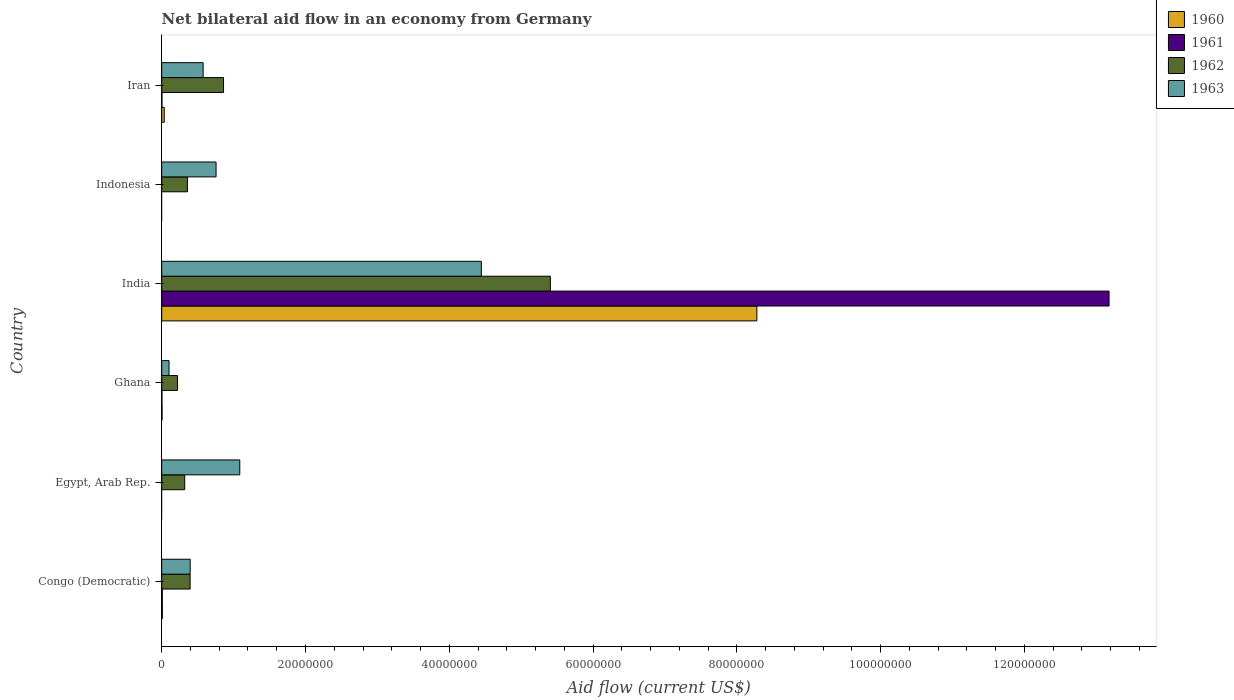How many groups of bars are there?
Provide a short and direct response. 6. How many bars are there on the 6th tick from the bottom?
Keep it short and to the point. 4. Across all countries, what is the maximum net bilateral aid flow in 1961?
Give a very brief answer. 1.32e+08. Across all countries, what is the minimum net bilateral aid flow in 1960?
Make the answer very short. 0. In which country was the net bilateral aid flow in 1960 maximum?
Provide a short and direct response. India. What is the total net bilateral aid flow in 1963 in the graph?
Ensure brevity in your answer.  7.36e+07. What is the difference between the net bilateral aid flow in 1962 in Congo (Democratic) and that in Iran?
Your answer should be very brief. -4.65e+06. What is the difference between the net bilateral aid flow in 1960 in Egypt, Arab Rep. and the net bilateral aid flow in 1963 in Indonesia?
Ensure brevity in your answer.  -7.56e+06. What is the average net bilateral aid flow in 1961 per country?
Give a very brief answer. 2.20e+07. What is the difference between the net bilateral aid flow in 1962 and net bilateral aid flow in 1963 in Iran?
Make the answer very short. 2.84e+06. In how many countries, is the net bilateral aid flow in 1960 greater than 116000000 US$?
Ensure brevity in your answer.  0. What is the ratio of the net bilateral aid flow in 1962 in Congo (Democratic) to that in Egypt, Arab Rep.?
Ensure brevity in your answer.  1.23. What is the difference between the highest and the second highest net bilateral aid flow in 1962?
Make the answer very short. 4.55e+07. What is the difference between the highest and the lowest net bilateral aid flow in 1960?
Ensure brevity in your answer.  8.28e+07. In how many countries, is the net bilateral aid flow in 1961 greater than the average net bilateral aid flow in 1961 taken over all countries?
Your response must be concise. 1. Is the sum of the net bilateral aid flow in 1962 in Ghana and Iran greater than the maximum net bilateral aid flow in 1963 across all countries?
Your answer should be compact. No. Is it the case that in every country, the sum of the net bilateral aid flow in 1960 and net bilateral aid flow in 1963 is greater than the sum of net bilateral aid flow in 1961 and net bilateral aid flow in 1962?
Keep it short and to the point. No. Is it the case that in every country, the sum of the net bilateral aid flow in 1963 and net bilateral aid flow in 1961 is greater than the net bilateral aid flow in 1962?
Your answer should be compact. No. How many bars are there?
Your answer should be compact. 20. Are all the bars in the graph horizontal?
Your answer should be compact. Yes. What is the difference between two consecutive major ticks on the X-axis?
Provide a succinct answer. 2.00e+07. Are the values on the major ticks of X-axis written in scientific E-notation?
Your response must be concise. No. Does the graph contain any zero values?
Provide a succinct answer. Yes. Does the graph contain grids?
Make the answer very short. No. Where does the legend appear in the graph?
Offer a very short reply. Top right. How many legend labels are there?
Provide a succinct answer. 4. What is the title of the graph?
Offer a very short reply. Net bilateral aid flow in an economy from Germany. What is the Aid flow (current US$) in 1960 in Congo (Democratic)?
Provide a succinct answer. 9.00e+04. What is the Aid flow (current US$) in 1962 in Congo (Democratic)?
Provide a succinct answer. 3.95e+06. What is the Aid flow (current US$) in 1963 in Congo (Democratic)?
Give a very brief answer. 3.96e+06. What is the Aid flow (current US$) in 1960 in Egypt, Arab Rep.?
Your answer should be very brief. 0. What is the Aid flow (current US$) in 1962 in Egypt, Arab Rep.?
Keep it short and to the point. 3.20e+06. What is the Aid flow (current US$) in 1963 in Egypt, Arab Rep.?
Your response must be concise. 1.09e+07. What is the Aid flow (current US$) of 1962 in Ghana?
Offer a very short reply. 2.20e+06. What is the Aid flow (current US$) of 1963 in Ghana?
Make the answer very short. 1.02e+06. What is the Aid flow (current US$) in 1960 in India?
Give a very brief answer. 8.28e+07. What is the Aid flow (current US$) of 1961 in India?
Offer a very short reply. 1.32e+08. What is the Aid flow (current US$) in 1962 in India?
Your response must be concise. 5.41e+07. What is the Aid flow (current US$) of 1963 in India?
Provide a short and direct response. 4.45e+07. What is the Aid flow (current US$) of 1961 in Indonesia?
Offer a very short reply. 0. What is the Aid flow (current US$) of 1962 in Indonesia?
Give a very brief answer. 3.58e+06. What is the Aid flow (current US$) in 1963 in Indonesia?
Offer a very short reply. 7.56e+06. What is the Aid flow (current US$) in 1960 in Iran?
Ensure brevity in your answer.  3.50e+05. What is the Aid flow (current US$) of 1962 in Iran?
Your answer should be compact. 8.60e+06. What is the Aid flow (current US$) in 1963 in Iran?
Offer a terse response. 5.76e+06. Across all countries, what is the maximum Aid flow (current US$) of 1960?
Make the answer very short. 8.28e+07. Across all countries, what is the maximum Aid flow (current US$) in 1961?
Ensure brevity in your answer.  1.32e+08. Across all countries, what is the maximum Aid flow (current US$) of 1962?
Make the answer very short. 5.41e+07. Across all countries, what is the maximum Aid flow (current US$) in 1963?
Your answer should be very brief. 4.45e+07. Across all countries, what is the minimum Aid flow (current US$) in 1960?
Your response must be concise. 0. Across all countries, what is the minimum Aid flow (current US$) in 1962?
Make the answer very short. 2.20e+06. Across all countries, what is the minimum Aid flow (current US$) in 1963?
Provide a succinct answer. 1.02e+06. What is the total Aid flow (current US$) of 1960 in the graph?
Your response must be concise. 8.33e+07. What is the total Aid flow (current US$) of 1961 in the graph?
Keep it short and to the point. 1.32e+08. What is the total Aid flow (current US$) of 1962 in the graph?
Your answer should be compact. 7.56e+07. What is the total Aid flow (current US$) in 1963 in the graph?
Ensure brevity in your answer.  7.36e+07. What is the difference between the Aid flow (current US$) of 1962 in Congo (Democratic) and that in Egypt, Arab Rep.?
Make the answer very short. 7.50e+05. What is the difference between the Aid flow (current US$) in 1963 in Congo (Democratic) and that in Egypt, Arab Rep.?
Provide a succinct answer. -6.90e+06. What is the difference between the Aid flow (current US$) in 1960 in Congo (Democratic) and that in Ghana?
Your answer should be very brief. 4.00e+04. What is the difference between the Aid flow (current US$) in 1962 in Congo (Democratic) and that in Ghana?
Provide a short and direct response. 1.75e+06. What is the difference between the Aid flow (current US$) of 1963 in Congo (Democratic) and that in Ghana?
Your answer should be compact. 2.94e+06. What is the difference between the Aid flow (current US$) in 1960 in Congo (Democratic) and that in India?
Provide a succinct answer. -8.27e+07. What is the difference between the Aid flow (current US$) in 1961 in Congo (Democratic) and that in India?
Provide a short and direct response. -1.32e+08. What is the difference between the Aid flow (current US$) of 1962 in Congo (Democratic) and that in India?
Offer a terse response. -5.01e+07. What is the difference between the Aid flow (current US$) in 1963 in Congo (Democratic) and that in India?
Your answer should be compact. -4.05e+07. What is the difference between the Aid flow (current US$) of 1963 in Congo (Democratic) and that in Indonesia?
Your answer should be very brief. -3.60e+06. What is the difference between the Aid flow (current US$) in 1961 in Congo (Democratic) and that in Iran?
Provide a short and direct response. 5.00e+04. What is the difference between the Aid flow (current US$) in 1962 in Congo (Democratic) and that in Iran?
Provide a short and direct response. -4.65e+06. What is the difference between the Aid flow (current US$) of 1963 in Congo (Democratic) and that in Iran?
Ensure brevity in your answer.  -1.80e+06. What is the difference between the Aid flow (current US$) in 1962 in Egypt, Arab Rep. and that in Ghana?
Offer a terse response. 1.00e+06. What is the difference between the Aid flow (current US$) in 1963 in Egypt, Arab Rep. and that in Ghana?
Your response must be concise. 9.84e+06. What is the difference between the Aid flow (current US$) in 1962 in Egypt, Arab Rep. and that in India?
Your response must be concise. -5.09e+07. What is the difference between the Aid flow (current US$) of 1963 in Egypt, Arab Rep. and that in India?
Provide a short and direct response. -3.36e+07. What is the difference between the Aid flow (current US$) of 1962 in Egypt, Arab Rep. and that in Indonesia?
Your answer should be very brief. -3.80e+05. What is the difference between the Aid flow (current US$) of 1963 in Egypt, Arab Rep. and that in Indonesia?
Your answer should be very brief. 3.30e+06. What is the difference between the Aid flow (current US$) of 1962 in Egypt, Arab Rep. and that in Iran?
Provide a succinct answer. -5.40e+06. What is the difference between the Aid flow (current US$) in 1963 in Egypt, Arab Rep. and that in Iran?
Ensure brevity in your answer.  5.10e+06. What is the difference between the Aid flow (current US$) of 1960 in Ghana and that in India?
Your answer should be compact. -8.27e+07. What is the difference between the Aid flow (current US$) of 1961 in Ghana and that in India?
Keep it short and to the point. -1.32e+08. What is the difference between the Aid flow (current US$) of 1962 in Ghana and that in India?
Your response must be concise. -5.19e+07. What is the difference between the Aid flow (current US$) in 1963 in Ghana and that in India?
Your response must be concise. -4.34e+07. What is the difference between the Aid flow (current US$) in 1962 in Ghana and that in Indonesia?
Make the answer very short. -1.38e+06. What is the difference between the Aid flow (current US$) in 1963 in Ghana and that in Indonesia?
Ensure brevity in your answer.  -6.54e+06. What is the difference between the Aid flow (current US$) in 1960 in Ghana and that in Iran?
Make the answer very short. -3.00e+05. What is the difference between the Aid flow (current US$) in 1961 in Ghana and that in Iran?
Offer a very short reply. 0. What is the difference between the Aid flow (current US$) of 1962 in Ghana and that in Iran?
Provide a short and direct response. -6.40e+06. What is the difference between the Aid flow (current US$) in 1963 in Ghana and that in Iran?
Give a very brief answer. -4.74e+06. What is the difference between the Aid flow (current US$) in 1962 in India and that in Indonesia?
Make the answer very short. 5.05e+07. What is the difference between the Aid flow (current US$) in 1963 in India and that in Indonesia?
Give a very brief answer. 3.69e+07. What is the difference between the Aid flow (current US$) of 1960 in India and that in Iran?
Keep it short and to the point. 8.24e+07. What is the difference between the Aid flow (current US$) in 1961 in India and that in Iran?
Offer a terse response. 1.32e+08. What is the difference between the Aid flow (current US$) in 1962 in India and that in Iran?
Provide a short and direct response. 4.55e+07. What is the difference between the Aid flow (current US$) in 1963 in India and that in Iran?
Your answer should be compact. 3.87e+07. What is the difference between the Aid flow (current US$) in 1962 in Indonesia and that in Iran?
Give a very brief answer. -5.02e+06. What is the difference between the Aid flow (current US$) of 1963 in Indonesia and that in Iran?
Offer a terse response. 1.80e+06. What is the difference between the Aid flow (current US$) in 1960 in Congo (Democratic) and the Aid flow (current US$) in 1962 in Egypt, Arab Rep.?
Your answer should be compact. -3.11e+06. What is the difference between the Aid flow (current US$) in 1960 in Congo (Democratic) and the Aid flow (current US$) in 1963 in Egypt, Arab Rep.?
Give a very brief answer. -1.08e+07. What is the difference between the Aid flow (current US$) of 1961 in Congo (Democratic) and the Aid flow (current US$) of 1962 in Egypt, Arab Rep.?
Offer a very short reply. -3.12e+06. What is the difference between the Aid flow (current US$) in 1961 in Congo (Democratic) and the Aid flow (current US$) in 1963 in Egypt, Arab Rep.?
Provide a short and direct response. -1.08e+07. What is the difference between the Aid flow (current US$) in 1962 in Congo (Democratic) and the Aid flow (current US$) in 1963 in Egypt, Arab Rep.?
Provide a short and direct response. -6.91e+06. What is the difference between the Aid flow (current US$) in 1960 in Congo (Democratic) and the Aid flow (current US$) in 1962 in Ghana?
Ensure brevity in your answer.  -2.11e+06. What is the difference between the Aid flow (current US$) in 1960 in Congo (Democratic) and the Aid flow (current US$) in 1963 in Ghana?
Ensure brevity in your answer.  -9.30e+05. What is the difference between the Aid flow (current US$) of 1961 in Congo (Democratic) and the Aid flow (current US$) of 1962 in Ghana?
Offer a terse response. -2.12e+06. What is the difference between the Aid flow (current US$) of 1961 in Congo (Democratic) and the Aid flow (current US$) of 1963 in Ghana?
Keep it short and to the point. -9.40e+05. What is the difference between the Aid flow (current US$) in 1962 in Congo (Democratic) and the Aid flow (current US$) in 1963 in Ghana?
Keep it short and to the point. 2.93e+06. What is the difference between the Aid flow (current US$) of 1960 in Congo (Democratic) and the Aid flow (current US$) of 1961 in India?
Provide a succinct answer. -1.32e+08. What is the difference between the Aid flow (current US$) of 1960 in Congo (Democratic) and the Aid flow (current US$) of 1962 in India?
Keep it short and to the point. -5.40e+07. What is the difference between the Aid flow (current US$) in 1960 in Congo (Democratic) and the Aid flow (current US$) in 1963 in India?
Give a very brief answer. -4.44e+07. What is the difference between the Aid flow (current US$) of 1961 in Congo (Democratic) and the Aid flow (current US$) of 1962 in India?
Make the answer very short. -5.40e+07. What is the difference between the Aid flow (current US$) of 1961 in Congo (Democratic) and the Aid flow (current US$) of 1963 in India?
Provide a succinct answer. -4.44e+07. What is the difference between the Aid flow (current US$) in 1962 in Congo (Democratic) and the Aid flow (current US$) in 1963 in India?
Your answer should be very brief. -4.05e+07. What is the difference between the Aid flow (current US$) of 1960 in Congo (Democratic) and the Aid flow (current US$) of 1962 in Indonesia?
Your answer should be very brief. -3.49e+06. What is the difference between the Aid flow (current US$) of 1960 in Congo (Democratic) and the Aid flow (current US$) of 1963 in Indonesia?
Ensure brevity in your answer.  -7.47e+06. What is the difference between the Aid flow (current US$) of 1961 in Congo (Democratic) and the Aid flow (current US$) of 1962 in Indonesia?
Ensure brevity in your answer.  -3.50e+06. What is the difference between the Aid flow (current US$) of 1961 in Congo (Democratic) and the Aid flow (current US$) of 1963 in Indonesia?
Make the answer very short. -7.48e+06. What is the difference between the Aid flow (current US$) in 1962 in Congo (Democratic) and the Aid flow (current US$) in 1963 in Indonesia?
Offer a terse response. -3.61e+06. What is the difference between the Aid flow (current US$) of 1960 in Congo (Democratic) and the Aid flow (current US$) of 1962 in Iran?
Keep it short and to the point. -8.51e+06. What is the difference between the Aid flow (current US$) in 1960 in Congo (Democratic) and the Aid flow (current US$) in 1963 in Iran?
Provide a succinct answer. -5.67e+06. What is the difference between the Aid flow (current US$) in 1961 in Congo (Democratic) and the Aid flow (current US$) in 1962 in Iran?
Ensure brevity in your answer.  -8.52e+06. What is the difference between the Aid flow (current US$) of 1961 in Congo (Democratic) and the Aid flow (current US$) of 1963 in Iran?
Provide a short and direct response. -5.68e+06. What is the difference between the Aid flow (current US$) of 1962 in Congo (Democratic) and the Aid flow (current US$) of 1963 in Iran?
Make the answer very short. -1.81e+06. What is the difference between the Aid flow (current US$) of 1962 in Egypt, Arab Rep. and the Aid flow (current US$) of 1963 in Ghana?
Offer a very short reply. 2.18e+06. What is the difference between the Aid flow (current US$) of 1962 in Egypt, Arab Rep. and the Aid flow (current US$) of 1963 in India?
Offer a very short reply. -4.13e+07. What is the difference between the Aid flow (current US$) in 1962 in Egypt, Arab Rep. and the Aid flow (current US$) in 1963 in Indonesia?
Your response must be concise. -4.36e+06. What is the difference between the Aid flow (current US$) of 1962 in Egypt, Arab Rep. and the Aid flow (current US$) of 1963 in Iran?
Your response must be concise. -2.56e+06. What is the difference between the Aid flow (current US$) in 1960 in Ghana and the Aid flow (current US$) in 1961 in India?
Give a very brief answer. -1.32e+08. What is the difference between the Aid flow (current US$) in 1960 in Ghana and the Aid flow (current US$) in 1962 in India?
Offer a terse response. -5.40e+07. What is the difference between the Aid flow (current US$) of 1960 in Ghana and the Aid flow (current US$) of 1963 in India?
Give a very brief answer. -4.44e+07. What is the difference between the Aid flow (current US$) of 1961 in Ghana and the Aid flow (current US$) of 1962 in India?
Your answer should be very brief. -5.40e+07. What is the difference between the Aid flow (current US$) in 1961 in Ghana and the Aid flow (current US$) in 1963 in India?
Your answer should be compact. -4.44e+07. What is the difference between the Aid flow (current US$) in 1962 in Ghana and the Aid flow (current US$) in 1963 in India?
Your response must be concise. -4.23e+07. What is the difference between the Aid flow (current US$) in 1960 in Ghana and the Aid flow (current US$) in 1962 in Indonesia?
Your answer should be compact. -3.53e+06. What is the difference between the Aid flow (current US$) in 1960 in Ghana and the Aid flow (current US$) in 1963 in Indonesia?
Your answer should be compact. -7.51e+06. What is the difference between the Aid flow (current US$) in 1961 in Ghana and the Aid flow (current US$) in 1962 in Indonesia?
Provide a succinct answer. -3.55e+06. What is the difference between the Aid flow (current US$) of 1961 in Ghana and the Aid flow (current US$) of 1963 in Indonesia?
Keep it short and to the point. -7.53e+06. What is the difference between the Aid flow (current US$) in 1962 in Ghana and the Aid flow (current US$) in 1963 in Indonesia?
Provide a short and direct response. -5.36e+06. What is the difference between the Aid flow (current US$) of 1960 in Ghana and the Aid flow (current US$) of 1962 in Iran?
Offer a very short reply. -8.55e+06. What is the difference between the Aid flow (current US$) in 1960 in Ghana and the Aid flow (current US$) in 1963 in Iran?
Your response must be concise. -5.71e+06. What is the difference between the Aid flow (current US$) of 1961 in Ghana and the Aid flow (current US$) of 1962 in Iran?
Make the answer very short. -8.57e+06. What is the difference between the Aid flow (current US$) in 1961 in Ghana and the Aid flow (current US$) in 1963 in Iran?
Provide a succinct answer. -5.73e+06. What is the difference between the Aid flow (current US$) in 1962 in Ghana and the Aid flow (current US$) in 1963 in Iran?
Your answer should be very brief. -3.56e+06. What is the difference between the Aid flow (current US$) of 1960 in India and the Aid flow (current US$) of 1962 in Indonesia?
Your response must be concise. 7.92e+07. What is the difference between the Aid flow (current US$) in 1960 in India and the Aid flow (current US$) in 1963 in Indonesia?
Your answer should be very brief. 7.52e+07. What is the difference between the Aid flow (current US$) in 1961 in India and the Aid flow (current US$) in 1962 in Indonesia?
Give a very brief answer. 1.28e+08. What is the difference between the Aid flow (current US$) of 1961 in India and the Aid flow (current US$) of 1963 in Indonesia?
Give a very brief answer. 1.24e+08. What is the difference between the Aid flow (current US$) in 1962 in India and the Aid flow (current US$) in 1963 in Indonesia?
Ensure brevity in your answer.  4.65e+07. What is the difference between the Aid flow (current US$) in 1960 in India and the Aid flow (current US$) in 1961 in Iran?
Give a very brief answer. 8.28e+07. What is the difference between the Aid flow (current US$) of 1960 in India and the Aid flow (current US$) of 1962 in Iran?
Offer a very short reply. 7.42e+07. What is the difference between the Aid flow (current US$) in 1960 in India and the Aid flow (current US$) in 1963 in Iran?
Your response must be concise. 7.70e+07. What is the difference between the Aid flow (current US$) in 1961 in India and the Aid flow (current US$) in 1962 in Iran?
Your response must be concise. 1.23e+08. What is the difference between the Aid flow (current US$) of 1961 in India and the Aid flow (current US$) of 1963 in Iran?
Offer a terse response. 1.26e+08. What is the difference between the Aid flow (current US$) of 1962 in India and the Aid flow (current US$) of 1963 in Iran?
Provide a short and direct response. 4.83e+07. What is the difference between the Aid flow (current US$) in 1962 in Indonesia and the Aid flow (current US$) in 1963 in Iran?
Offer a terse response. -2.18e+06. What is the average Aid flow (current US$) of 1960 per country?
Make the answer very short. 1.39e+07. What is the average Aid flow (current US$) of 1961 per country?
Your response must be concise. 2.20e+07. What is the average Aid flow (current US$) in 1962 per country?
Offer a terse response. 1.26e+07. What is the average Aid flow (current US$) of 1963 per country?
Offer a terse response. 1.23e+07. What is the difference between the Aid flow (current US$) of 1960 and Aid flow (current US$) of 1961 in Congo (Democratic)?
Your answer should be compact. 10000. What is the difference between the Aid flow (current US$) of 1960 and Aid flow (current US$) of 1962 in Congo (Democratic)?
Provide a succinct answer. -3.86e+06. What is the difference between the Aid flow (current US$) in 1960 and Aid flow (current US$) in 1963 in Congo (Democratic)?
Your answer should be compact. -3.87e+06. What is the difference between the Aid flow (current US$) in 1961 and Aid flow (current US$) in 1962 in Congo (Democratic)?
Your response must be concise. -3.87e+06. What is the difference between the Aid flow (current US$) in 1961 and Aid flow (current US$) in 1963 in Congo (Democratic)?
Provide a succinct answer. -3.88e+06. What is the difference between the Aid flow (current US$) in 1962 and Aid flow (current US$) in 1963 in Egypt, Arab Rep.?
Your answer should be very brief. -7.66e+06. What is the difference between the Aid flow (current US$) in 1960 and Aid flow (current US$) in 1962 in Ghana?
Provide a short and direct response. -2.15e+06. What is the difference between the Aid flow (current US$) of 1960 and Aid flow (current US$) of 1963 in Ghana?
Provide a short and direct response. -9.70e+05. What is the difference between the Aid flow (current US$) of 1961 and Aid flow (current US$) of 1962 in Ghana?
Make the answer very short. -2.17e+06. What is the difference between the Aid flow (current US$) of 1961 and Aid flow (current US$) of 1963 in Ghana?
Give a very brief answer. -9.90e+05. What is the difference between the Aid flow (current US$) in 1962 and Aid flow (current US$) in 1963 in Ghana?
Your answer should be very brief. 1.18e+06. What is the difference between the Aid flow (current US$) in 1960 and Aid flow (current US$) in 1961 in India?
Keep it short and to the point. -4.90e+07. What is the difference between the Aid flow (current US$) of 1960 and Aid flow (current US$) of 1962 in India?
Make the answer very short. 2.87e+07. What is the difference between the Aid flow (current US$) in 1960 and Aid flow (current US$) in 1963 in India?
Keep it short and to the point. 3.83e+07. What is the difference between the Aid flow (current US$) of 1961 and Aid flow (current US$) of 1962 in India?
Offer a very short reply. 7.77e+07. What is the difference between the Aid flow (current US$) of 1961 and Aid flow (current US$) of 1963 in India?
Make the answer very short. 8.73e+07. What is the difference between the Aid flow (current US$) in 1962 and Aid flow (current US$) in 1963 in India?
Ensure brevity in your answer.  9.60e+06. What is the difference between the Aid flow (current US$) of 1962 and Aid flow (current US$) of 1963 in Indonesia?
Offer a terse response. -3.98e+06. What is the difference between the Aid flow (current US$) of 1960 and Aid flow (current US$) of 1961 in Iran?
Provide a succinct answer. 3.20e+05. What is the difference between the Aid flow (current US$) of 1960 and Aid flow (current US$) of 1962 in Iran?
Your answer should be compact. -8.25e+06. What is the difference between the Aid flow (current US$) of 1960 and Aid flow (current US$) of 1963 in Iran?
Provide a short and direct response. -5.41e+06. What is the difference between the Aid flow (current US$) of 1961 and Aid flow (current US$) of 1962 in Iran?
Keep it short and to the point. -8.57e+06. What is the difference between the Aid flow (current US$) of 1961 and Aid flow (current US$) of 1963 in Iran?
Make the answer very short. -5.73e+06. What is the difference between the Aid flow (current US$) of 1962 and Aid flow (current US$) of 1963 in Iran?
Keep it short and to the point. 2.84e+06. What is the ratio of the Aid flow (current US$) of 1962 in Congo (Democratic) to that in Egypt, Arab Rep.?
Ensure brevity in your answer.  1.23. What is the ratio of the Aid flow (current US$) in 1963 in Congo (Democratic) to that in Egypt, Arab Rep.?
Your response must be concise. 0.36. What is the ratio of the Aid flow (current US$) in 1960 in Congo (Democratic) to that in Ghana?
Give a very brief answer. 1.8. What is the ratio of the Aid flow (current US$) of 1961 in Congo (Democratic) to that in Ghana?
Your answer should be compact. 2.67. What is the ratio of the Aid flow (current US$) in 1962 in Congo (Democratic) to that in Ghana?
Make the answer very short. 1.8. What is the ratio of the Aid flow (current US$) in 1963 in Congo (Democratic) to that in Ghana?
Your answer should be very brief. 3.88. What is the ratio of the Aid flow (current US$) in 1960 in Congo (Democratic) to that in India?
Your answer should be compact. 0. What is the ratio of the Aid flow (current US$) in 1961 in Congo (Democratic) to that in India?
Make the answer very short. 0. What is the ratio of the Aid flow (current US$) in 1962 in Congo (Democratic) to that in India?
Provide a succinct answer. 0.07. What is the ratio of the Aid flow (current US$) of 1963 in Congo (Democratic) to that in India?
Offer a very short reply. 0.09. What is the ratio of the Aid flow (current US$) in 1962 in Congo (Democratic) to that in Indonesia?
Provide a short and direct response. 1.1. What is the ratio of the Aid flow (current US$) of 1963 in Congo (Democratic) to that in Indonesia?
Make the answer very short. 0.52. What is the ratio of the Aid flow (current US$) of 1960 in Congo (Democratic) to that in Iran?
Make the answer very short. 0.26. What is the ratio of the Aid flow (current US$) in 1961 in Congo (Democratic) to that in Iran?
Offer a very short reply. 2.67. What is the ratio of the Aid flow (current US$) of 1962 in Congo (Democratic) to that in Iran?
Offer a very short reply. 0.46. What is the ratio of the Aid flow (current US$) of 1963 in Congo (Democratic) to that in Iran?
Make the answer very short. 0.69. What is the ratio of the Aid flow (current US$) in 1962 in Egypt, Arab Rep. to that in Ghana?
Offer a very short reply. 1.45. What is the ratio of the Aid flow (current US$) in 1963 in Egypt, Arab Rep. to that in Ghana?
Give a very brief answer. 10.65. What is the ratio of the Aid flow (current US$) in 1962 in Egypt, Arab Rep. to that in India?
Your response must be concise. 0.06. What is the ratio of the Aid flow (current US$) of 1963 in Egypt, Arab Rep. to that in India?
Give a very brief answer. 0.24. What is the ratio of the Aid flow (current US$) of 1962 in Egypt, Arab Rep. to that in Indonesia?
Make the answer very short. 0.89. What is the ratio of the Aid flow (current US$) in 1963 in Egypt, Arab Rep. to that in Indonesia?
Offer a very short reply. 1.44. What is the ratio of the Aid flow (current US$) of 1962 in Egypt, Arab Rep. to that in Iran?
Make the answer very short. 0.37. What is the ratio of the Aid flow (current US$) in 1963 in Egypt, Arab Rep. to that in Iran?
Offer a very short reply. 1.89. What is the ratio of the Aid flow (current US$) of 1960 in Ghana to that in India?
Your answer should be compact. 0. What is the ratio of the Aid flow (current US$) of 1962 in Ghana to that in India?
Your answer should be very brief. 0.04. What is the ratio of the Aid flow (current US$) in 1963 in Ghana to that in India?
Provide a short and direct response. 0.02. What is the ratio of the Aid flow (current US$) of 1962 in Ghana to that in Indonesia?
Your answer should be compact. 0.61. What is the ratio of the Aid flow (current US$) in 1963 in Ghana to that in Indonesia?
Your answer should be compact. 0.13. What is the ratio of the Aid flow (current US$) in 1960 in Ghana to that in Iran?
Your answer should be compact. 0.14. What is the ratio of the Aid flow (current US$) in 1962 in Ghana to that in Iran?
Make the answer very short. 0.26. What is the ratio of the Aid flow (current US$) in 1963 in Ghana to that in Iran?
Offer a terse response. 0.18. What is the ratio of the Aid flow (current US$) in 1962 in India to that in Indonesia?
Keep it short and to the point. 15.1. What is the ratio of the Aid flow (current US$) in 1963 in India to that in Indonesia?
Your answer should be compact. 5.88. What is the ratio of the Aid flow (current US$) in 1960 in India to that in Iran?
Provide a succinct answer. 236.54. What is the ratio of the Aid flow (current US$) in 1961 in India to that in Iran?
Your answer should be very brief. 4392.67. What is the ratio of the Aid flow (current US$) of 1962 in India to that in Iran?
Your answer should be compact. 6.29. What is the ratio of the Aid flow (current US$) in 1963 in India to that in Iran?
Offer a terse response. 7.72. What is the ratio of the Aid flow (current US$) of 1962 in Indonesia to that in Iran?
Ensure brevity in your answer.  0.42. What is the ratio of the Aid flow (current US$) in 1963 in Indonesia to that in Iran?
Ensure brevity in your answer.  1.31. What is the difference between the highest and the second highest Aid flow (current US$) of 1960?
Make the answer very short. 8.24e+07. What is the difference between the highest and the second highest Aid flow (current US$) in 1961?
Keep it short and to the point. 1.32e+08. What is the difference between the highest and the second highest Aid flow (current US$) in 1962?
Make the answer very short. 4.55e+07. What is the difference between the highest and the second highest Aid flow (current US$) in 1963?
Keep it short and to the point. 3.36e+07. What is the difference between the highest and the lowest Aid flow (current US$) in 1960?
Provide a short and direct response. 8.28e+07. What is the difference between the highest and the lowest Aid flow (current US$) of 1961?
Your answer should be compact. 1.32e+08. What is the difference between the highest and the lowest Aid flow (current US$) of 1962?
Give a very brief answer. 5.19e+07. What is the difference between the highest and the lowest Aid flow (current US$) in 1963?
Your answer should be very brief. 4.34e+07. 